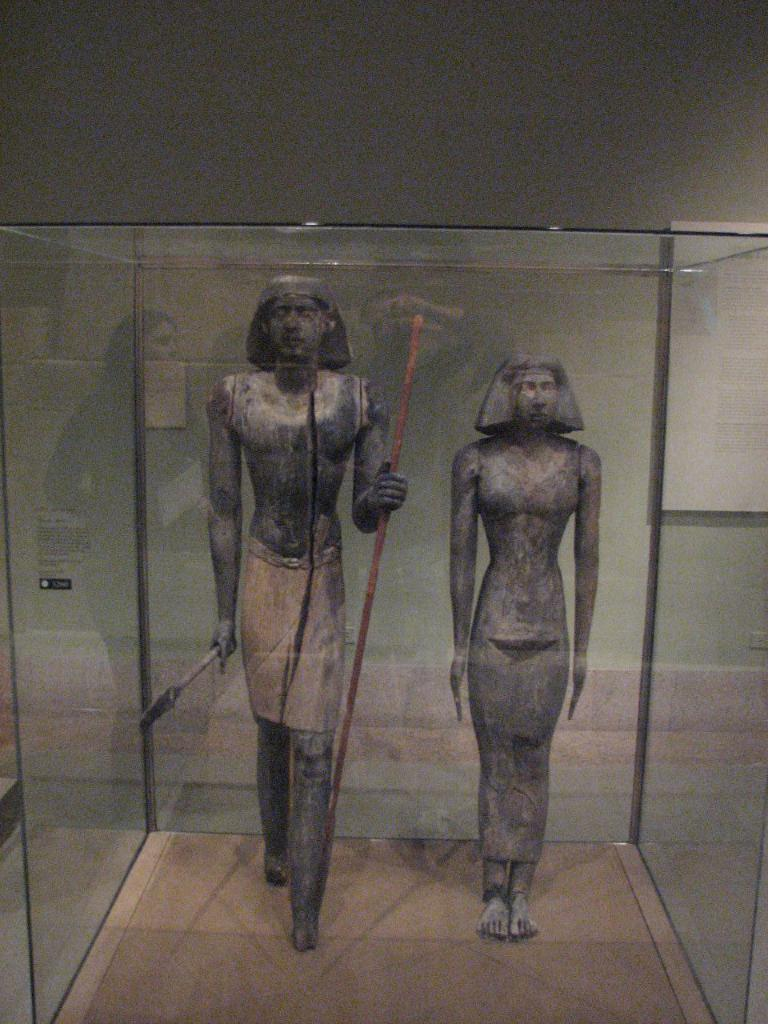How many statues are present in the image? There are two statues in the image. Can you describe the location or setting of the statues? The statues are inside a glass object. What type of screw is holding the statues together in the image? There is no screw present in the image; the statues are inside a glass object. What is the end result of the statues in the image? The image does not depict an end result, as it is a static representation of the statues inside a glass object. 